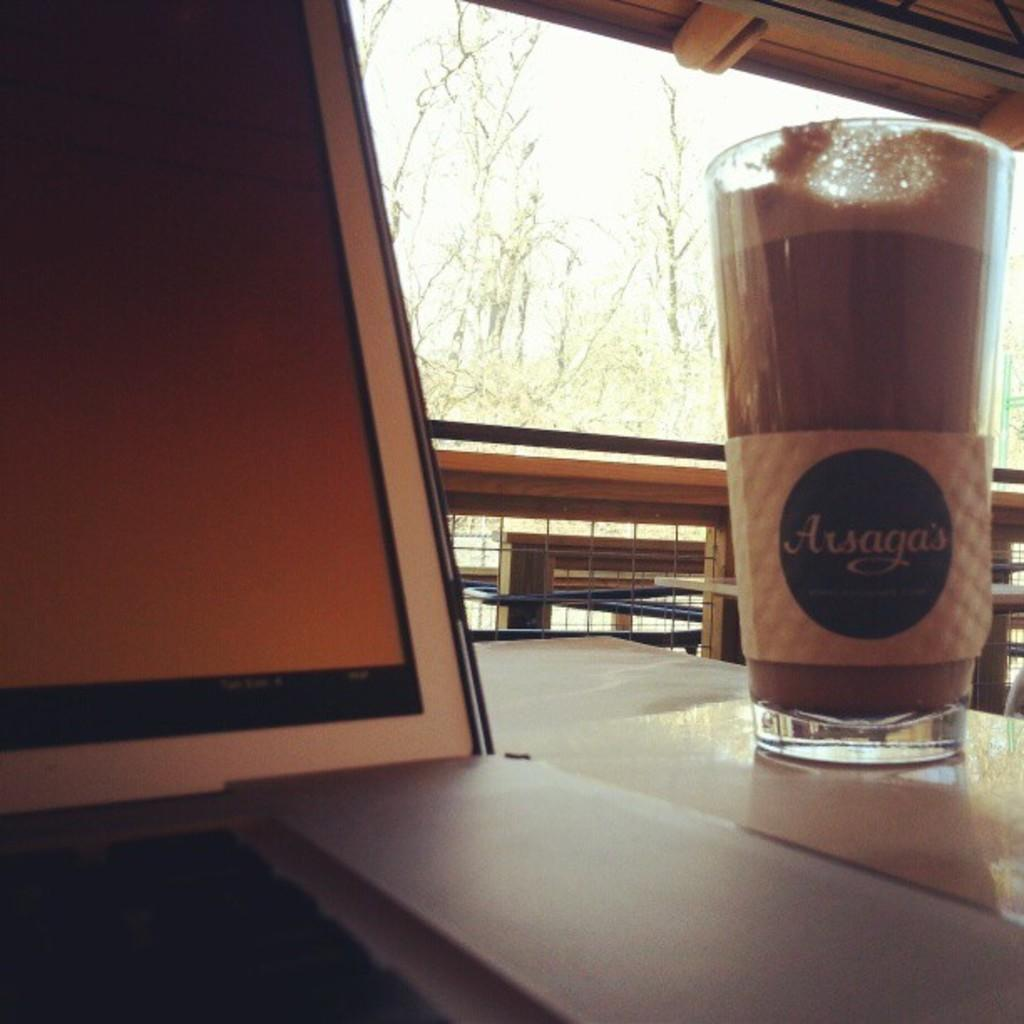What is on the table in the image? There is a juice glass on a table in the image. What type of objects can be seen made of wood in the image? There are wooden objects in the image. What can be used for cooking in the image? There are grills in the image. What is the flat, rectangular object in the image? There is a board in the image. What is visible in the background of the image? The sky is visible in the background of the image. What type of fruit is the governor holding in the image? There is no governor or fruit present in the image. What type of shop can be seen in the image? There is no shop present in the image. 